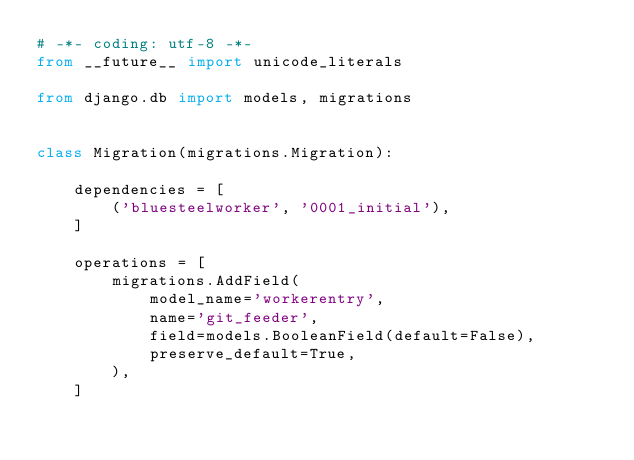<code> <loc_0><loc_0><loc_500><loc_500><_Python_># -*- coding: utf-8 -*-
from __future__ import unicode_literals

from django.db import models, migrations


class Migration(migrations.Migration):

    dependencies = [
        ('bluesteelworker', '0001_initial'),
    ]

    operations = [
        migrations.AddField(
            model_name='workerentry',
            name='git_feeder',
            field=models.BooleanField(default=False),
            preserve_default=True,
        ),
    ]
</code> 